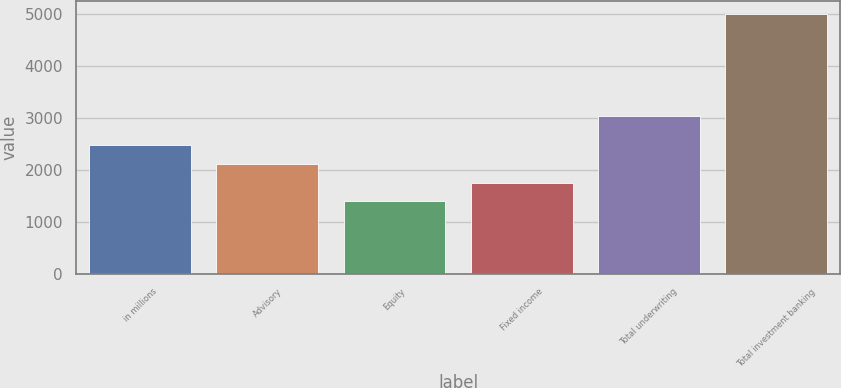Convert chart. <chart><loc_0><loc_0><loc_500><loc_500><bar_chart><fcel>in millions<fcel>Advisory<fcel>Equity<fcel>Fixed income<fcel>Total underwriting<fcel>Total investment banking<nl><fcel>2481<fcel>2120<fcel>1398<fcel>1759<fcel>3041<fcel>5008<nl></chart> 